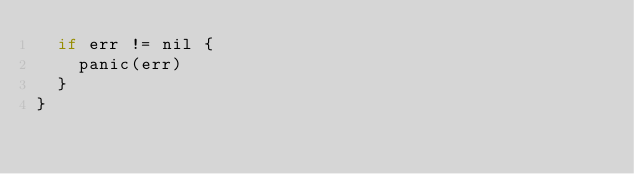Convert code to text. <code><loc_0><loc_0><loc_500><loc_500><_Go_>	if err != nil {
		panic(err)
	}
}
</code> 